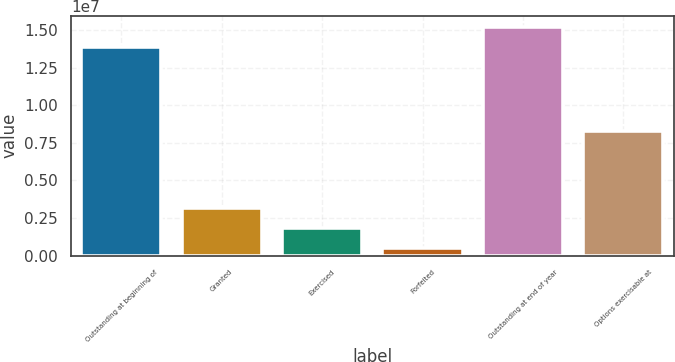Convert chart. <chart><loc_0><loc_0><loc_500><loc_500><bar_chart><fcel>Outstanding at beginning of<fcel>Granted<fcel>Exercised<fcel>Forfeited<fcel>Outstanding at end of year<fcel>Options exercisable at<nl><fcel>1.38551e+07<fcel>3.19417e+06<fcel>1.8573e+06<fcel>520432<fcel>1.5192e+07<fcel>8.31697e+06<nl></chart> 